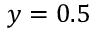Convert formula to latex. <formula><loc_0><loc_0><loc_500><loc_500>y = 0 . 5</formula> 